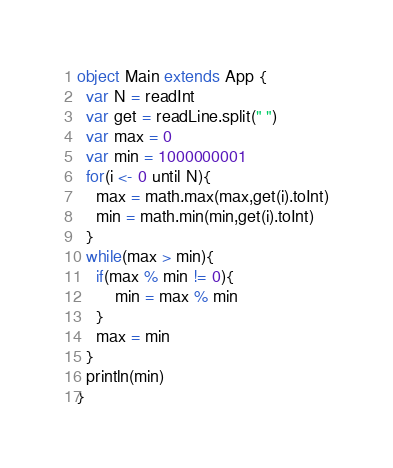Convert code to text. <code><loc_0><loc_0><loc_500><loc_500><_Scala_>object Main extends App {
  var N = readInt
  var get = readLine.split(" ")
  var max = 0
  var min = 1000000001
  for(i <- 0 until N){
    max = math.max(max,get(i).toInt)
    min = math.min(min,get(i).toInt)
  }
  while(max > min){
    if(max % min != 0){
	    min = max % min
    }
    max = min
  }
  println(min)
}</code> 